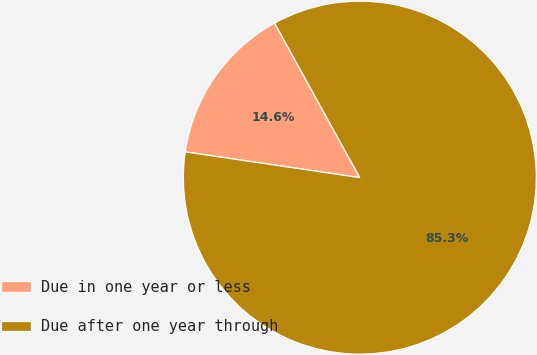Convert chart to OTSL. <chart><loc_0><loc_0><loc_500><loc_500><pie_chart><fcel>Due in one year or less<fcel>Due after one year through<nl><fcel>14.65%<fcel>85.35%<nl></chart> 